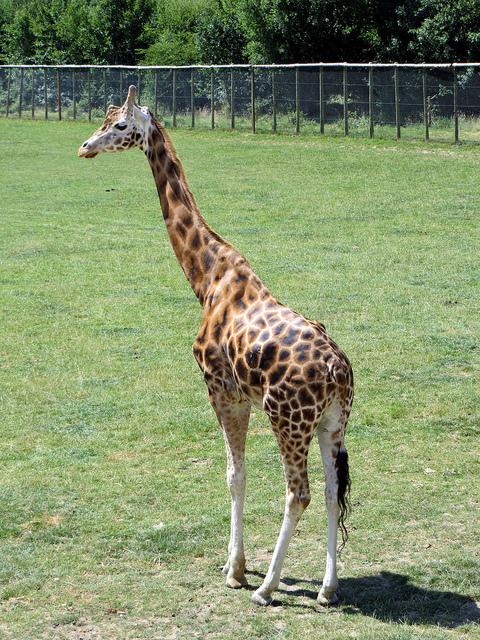Is the animal eating the tree?
Be succinct. No. Is the giraffe old?
Concise answer only. No. Is this giraffe in a zoo?
Short answer required. Yes. How many legs does the giraffe have?
Be succinct. 4. Is the giraffe moving or standing still?
Keep it brief. Standing still. Are we in a zoo?
Give a very brief answer. Yes. What type is the animal?
Short answer required. Giraffe. How many giraffes are there?
Short answer required. 1. Is this animal hungry?
Concise answer only. No. 